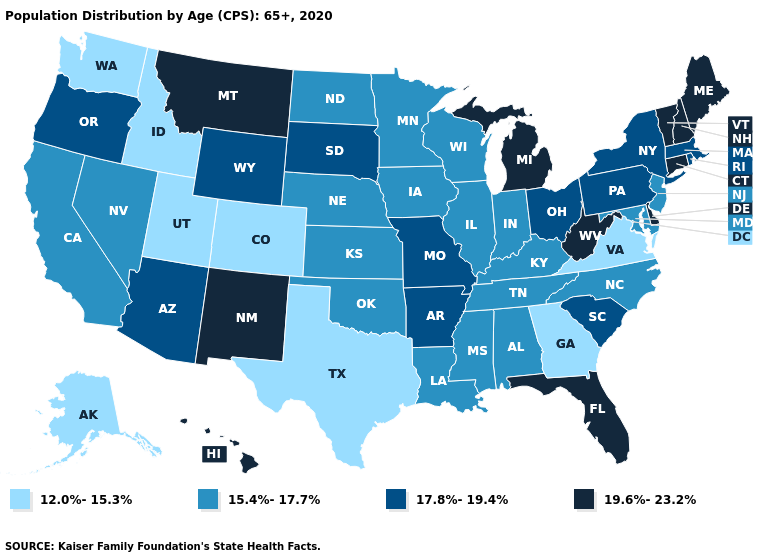What is the value of Louisiana?
Be succinct. 15.4%-17.7%. What is the value of Indiana?
Concise answer only. 15.4%-17.7%. Name the states that have a value in the range 17.8%-19.4%?
Answer briefly. Arizona, Arkansas, Massachusetts, Missouri, New York, Ohio, Oregon, Pennsylvania, Rhode Island, South Carolina, South Dakota, Wyoming. Does Utah have the lowest value in the USA?
Be succinct. Yes. Name the states that have a value in the range 12.0%-15.3%?
Short answer required. Alaska, Colorado, Georgia, Idaho, Texas, Utah, Virginia, Washington. What is the highest value in states that border Connecticut?
Short answer required. 17.8%-19.4%. What is the lowest value in the USA?
Short answer required. 12.0%-15.3%. Name the states that have a value in the range 15.4%-17.7%?
Be succinct. Alabama, California, Illinois, Indiana, Iowa, Kansas, Kentucky, Louisiana, Maryland, Minnesota, Mississippi, Nebraska, Nevada, New Jersey, North Carolina, North Dakota, Oklahoma, Tennessee, Wisconsin. What is the value of Texas?
Be succinct. 12.0%-15.3%. Among the states that border Missouri , which have the lowest value?
Answer briefly. Illinois, Iowa, Kansas, Kentucky, Nebraska, Oklahoma, Tennessee. Does Colorado have the lowest value in the West?
Short answer required. Yes. Which states have the lowest value in the Northeast?
Answer briefly. New Jersey. Name the states that have a value in the range 17.8%-19.4%?
Answer briefly. Arizona, Arkansas, Massachusetts, Missouri, New York, Ohio, Oregon, Pennsylvania, Rhode Island, South Carolina, South Dakota, Wyoming. What is the lowest value in the West?
Write a very short answer. 12.0%-15.3%. Name the states that have a value in the range 15.4%-17.7%?
Short answer required. Alabama, California, Illinois, Indiana, Iowa, Kansas, Kentucky, Louisiana, Maryland, Minnesota, Mississippi, Nebraska, Nevada, New Jersey, North Carolina, North Dakota, Oklahoma, Tennessee, Wisconsin. 